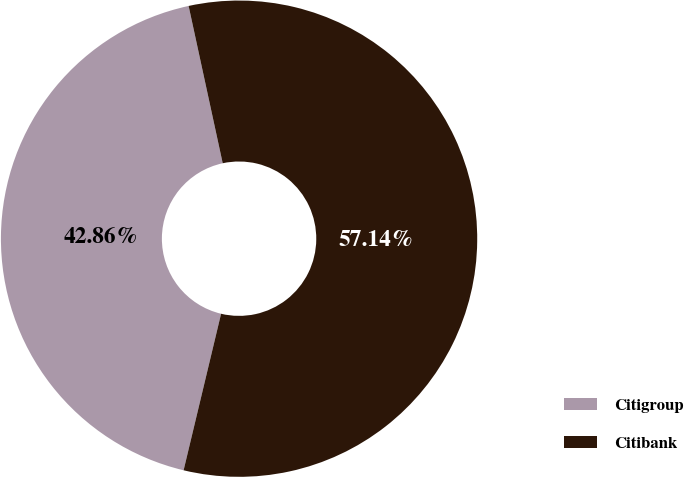Convert chart to OTSL. <chart><loc_0><loc_0><loc_500><loc_500><pie_chart><fcel>Citigroup<fcel>Citibank<nl><fcel>42.86%<fcel>57.14%<nl></chart> 